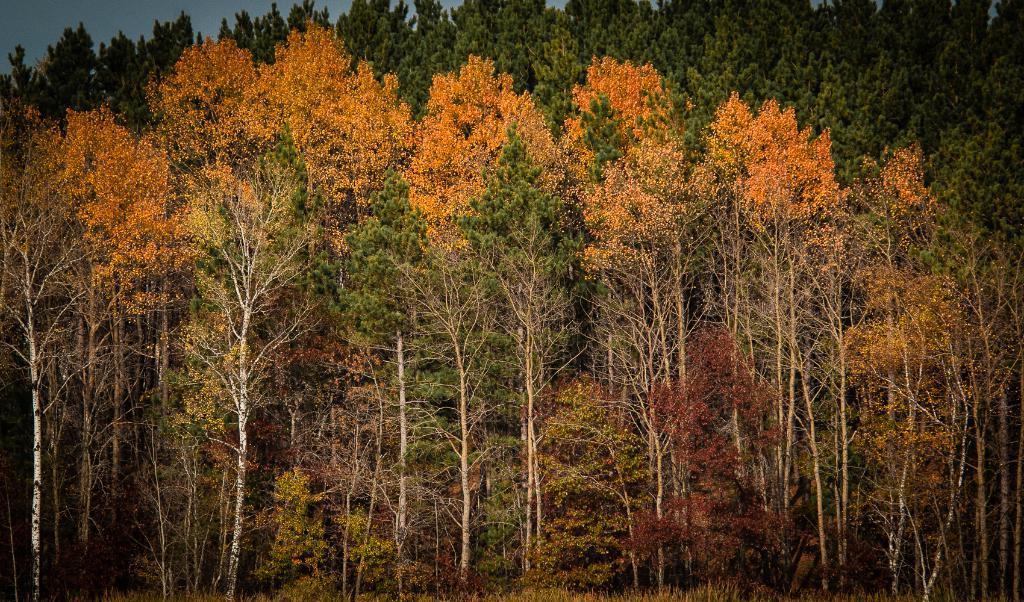Please provide a concise description of this image. In the image we can see some trees. 